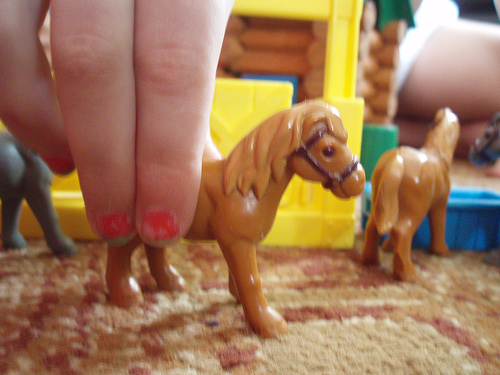<image>
Is there a finger on the horse? Yes. Looking at the image, I can see the finger is positioned on top of the horse, with the horse providing support. 